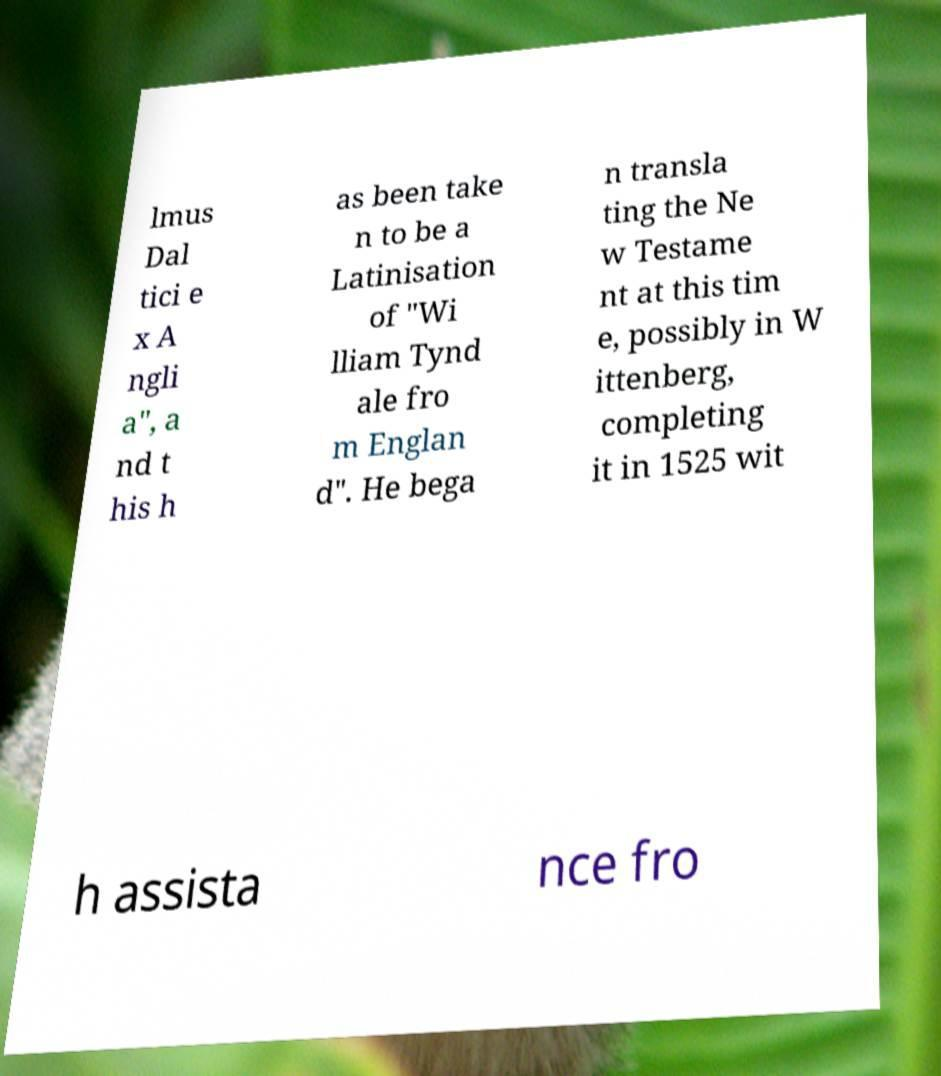Can you accurately transcribe the text from the provided image for me? lmus Dal tici e x A ngli a", a nd t his h as been take n to be a Latinisation of "Wi lliam Tynd ale fro m Englan d". He bega n transla ting the Ne w Testame nt at this tim e, possibly in W ittenberg, completing it in 1525 wit h assista nce fro 